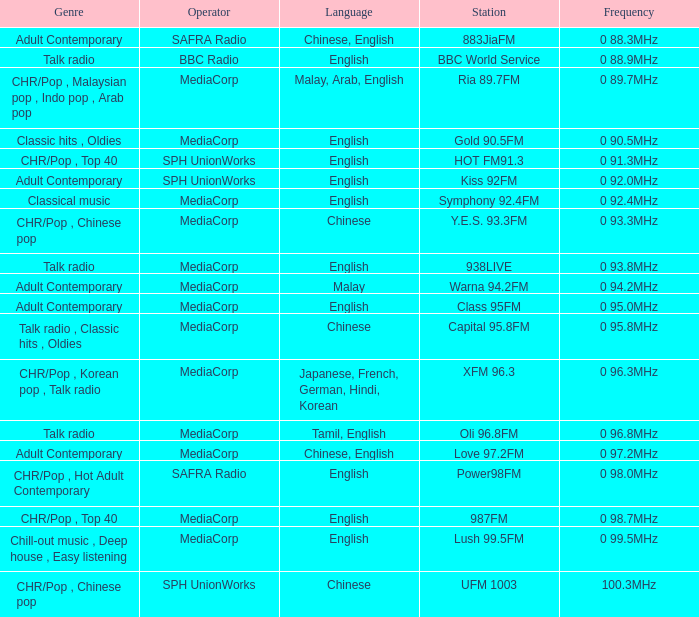Could you help me parse every detail presented in this table? {'header': ['Genre', 'Operator', 'Language', 'Station', 'Frequency'], 'rows': [['Adult Contemporary', 'SAFRA Radio', 'Chinese, English', '883JiaFM', '0 88.3MHz'], ['Talk radio', 'BBC Radio', 'English', 'BBC World Service', '0 88.9MHz'], ['CHR/Pop , Malaysian pop , Indo pop , Arab pop', 'MediaCorp', 'Malay, Arab, English', 'Ria 89.7FM', '0 89.7MHz'], ['Classic hits , Oldies', 'MediaCorp', 'English', 'Gold 90.5FM', '0 90.5MHz'], ['CHR/Pop , Top 40', 'SPH UnionWorks', 'English', 'HOT FM91.3', '0 91.3MHz'], ['Adult Contemporary', 'SPH UnionWorks', 'English', 'Kiss 92FM', '0 92.0MHz'], ['Classical music', 'MediaCorp', 'English', 'Symphony 92.4FM', '0 92.4MHz'], ['CHR/Pop , Chinese pop', 'MediaCorp', 'Chinese', 'Y.E.S. 93.3FM', '0 93.3MHz'], ['Talk radio', 'MediaCorp', 'English', '938LIVE', '0 93.8MHz'], ['Adult Contemporary', 'MediaCorp', 'Malay', 'Warna 94.2FM', '0 94.2MHz'], ['Adult Contemporary', 'MediaCorp', 'English', 'Class 95FM', '0 95.0MHz'], ['Talk radio , Classic hits , Oldies', 'MediaCorp', 'Chinese', 'Capital 95.8FM', '0 95.8MHz'], ['CHR/Pop , Korean pop , Talk radio', 'MediaCorp', 'Japanese, French, German, Hindi, Korean', 'XFM 96.3', '0 96.3MHz'], ['Talk radio', 'MediaCorp', 'Tamil, English', 'Oli 96.8FM', '0 96.8MHz'], ['Adult Contemporary', 'MediaCorp', 'Chinese, English', 'Love 97.2FM', '0 97.2MHz'], ['CHR/Pop , Hot Adult Contemporary', 'SAFRA Radio', 'English', 'Power98FM', '0 98.0MHz'], ['CHR/Pop , Top 40', 'MediaCorp', 'English', '987FM', '0 98.7MHz'], ['Chill-out music , Deep house , Easy listening', 'MediaCorp', 'English', 'Lush 99.5FM', '0 99.5MHz'], ['CHR/Pop , Chinese pop', 'SPH UnionWorks', 'Chinese', 'UFM 1003', '100.3MHz']]} What genre has a station of Class 95FM? Adult Contemporary. 